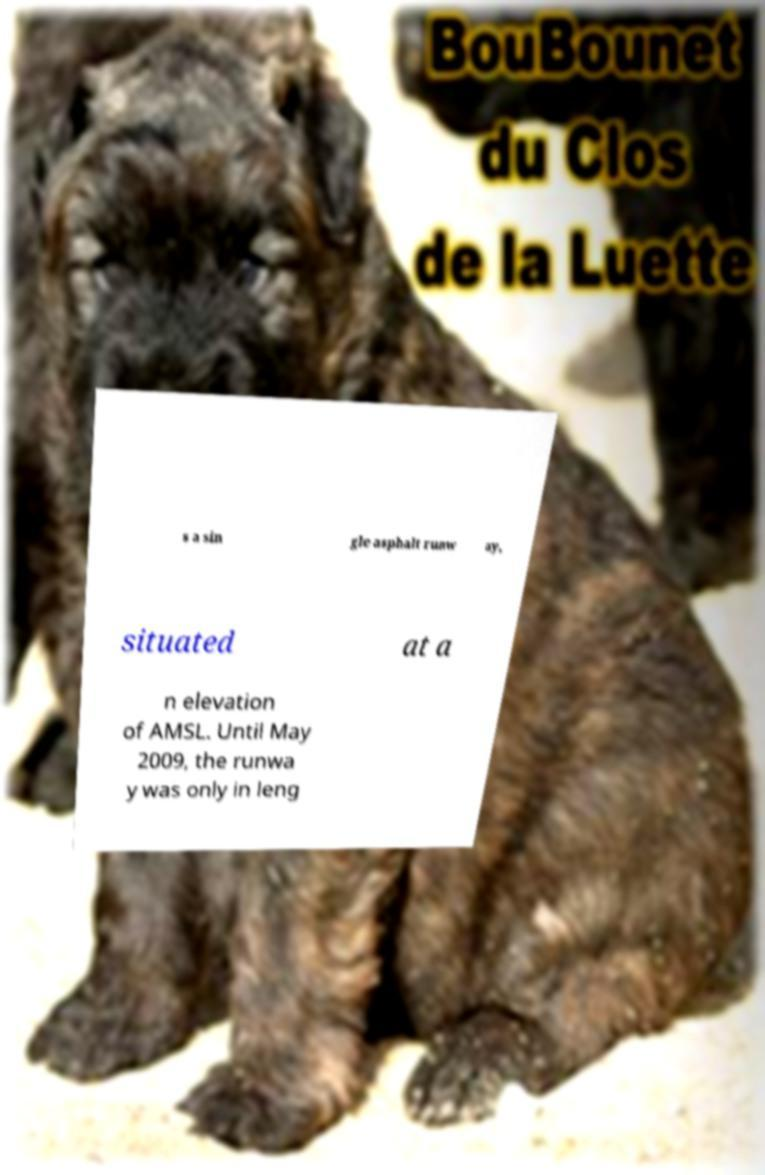What messages or text are displayed in this image? I need them in a readable, typed format. s a sin gle asphalt runw ay, situated at a n elevation of AMSL. Until May 2009, the runwa y was only in leng 